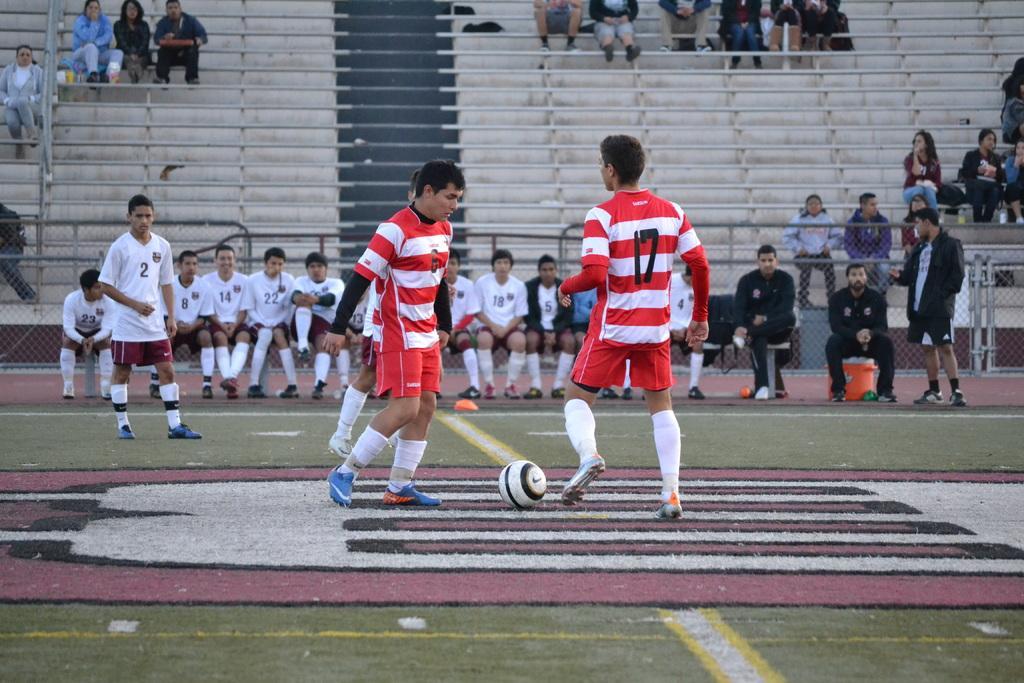Please provide a concise description of this image. The picture is taken in a football ground. In the foreground of the picture there are players playing football. In the center of the picture there are players sitting on the benches, behind them there is railing. At the top there are benches for audience, there are people sitting on the benches. 